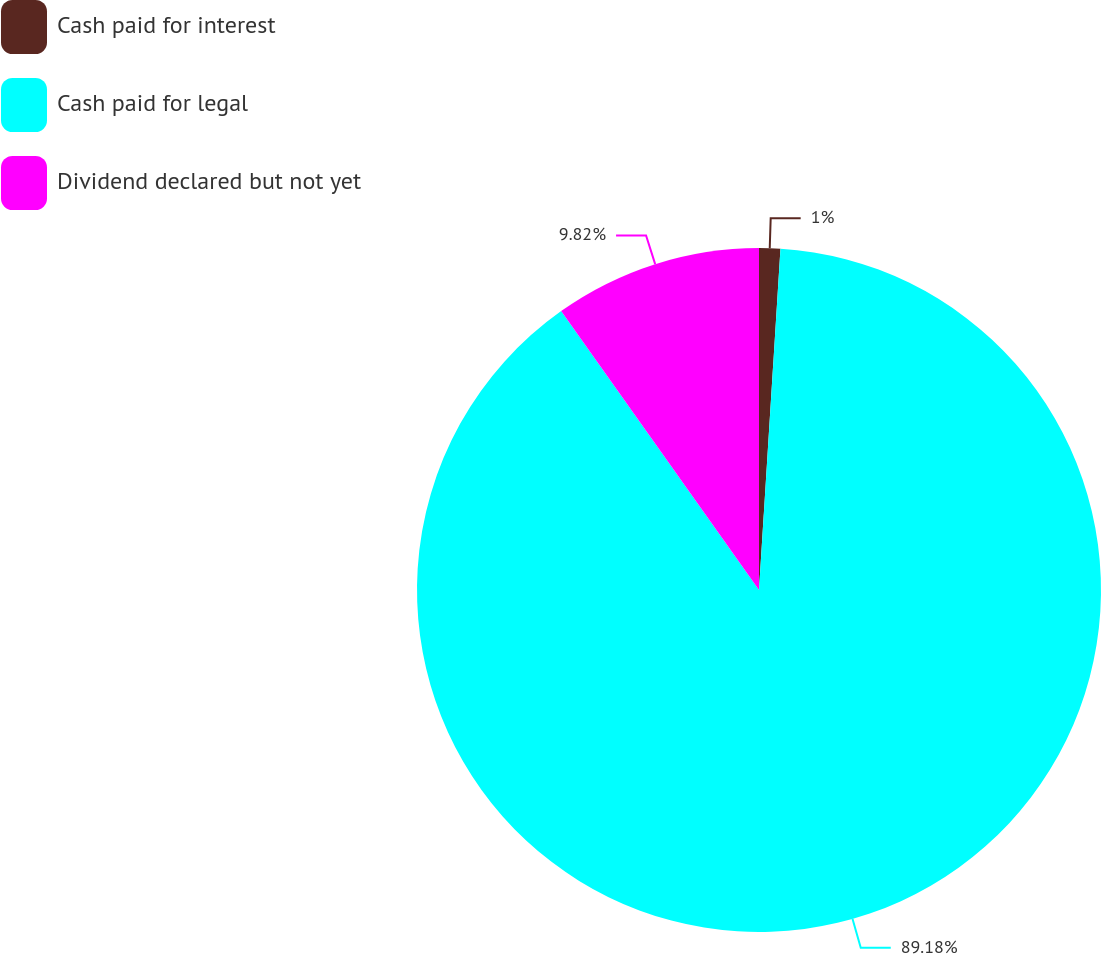Convert chart to OTSL. <chart><loc_0><loc_0><loc_500><loc_500><pie_chart><fcel>Cash paid for interest<fcel>Cash paid for legal<fcel>Dividend declared but not yet<nl><fcel>1.0%<fcel>89.19%<fcel>9.82%<nl></chart> 